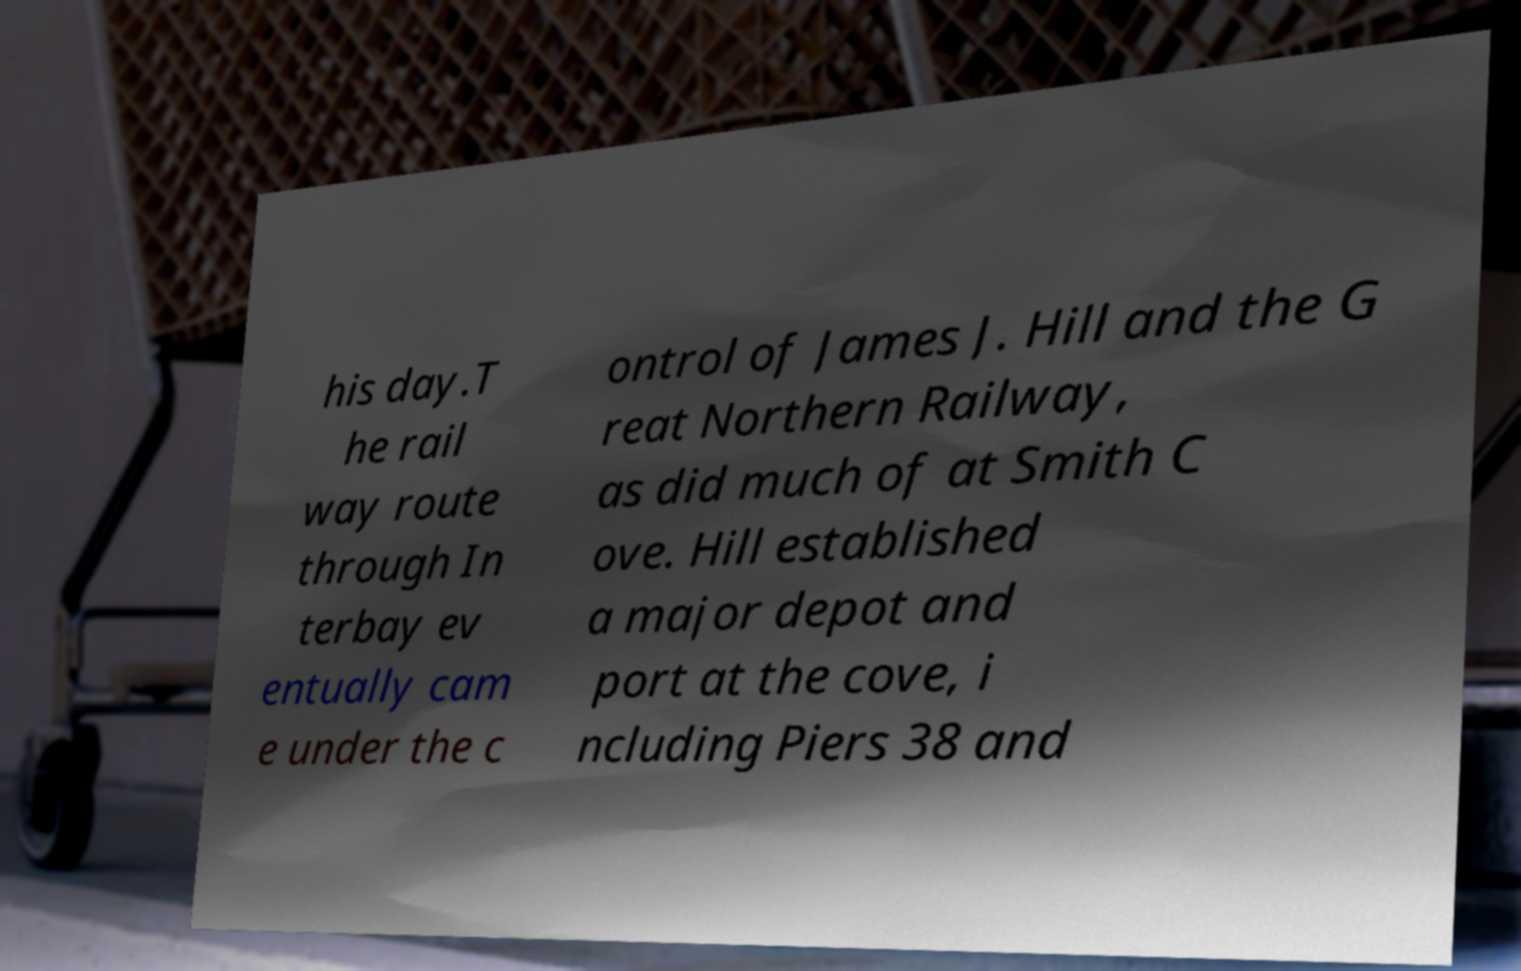There's text embedded in this image that I need extracted. Can you transcribe it verbatim? his day.T he rail way route through In terbay ev entually cam e under the c ontrol of James J. Hill and the G reat Northern Railway, as did much of at Smith C ove. Hill established a major depot and port at the cove, i ncluding Piers 38 and 